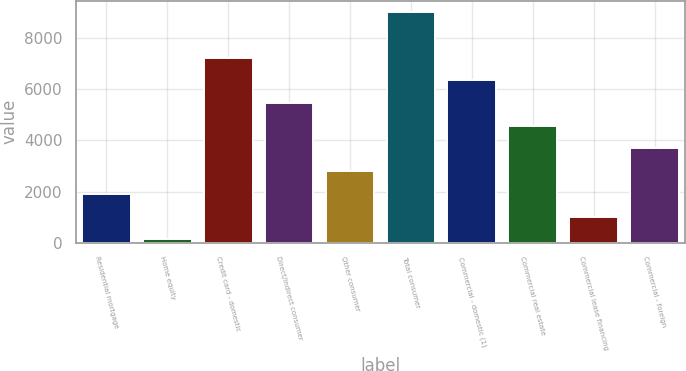Convert chart to OTSL. <chart><loc_0><loc_0><loc_500><loc_500><bar_chart><fcel>Residential mortgage<fcel>Home equity<fcel>Credit card - domestic<fcel>Direct/Indirect consumer<fcel>Other consumer<fcel>Total consumer<fcel>Commercial - domestic (1)<fcel>Commercial real estate<fcel>Commercial lease financing<fcel>Commercial - foreign<nl><fcel>1909.6<fcel>133<fcel>7239.4<fcel>5462.8<fcel>2797.9<fcel>9016<fcel>6351.1<fcel>4574.5<fcel>1021.3<fcel>3686.2<nl></chart> 